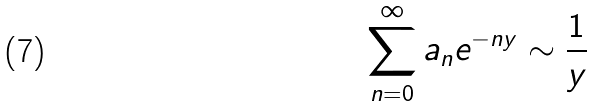Convert formula to latex. <formula><loc_0><loc_0><loc_500><loc_500>\sum _ { n = 0 } ^ { \infty } a _ { n } e ^ { - n y } \sim \frac { 1 } { y }</formula> 